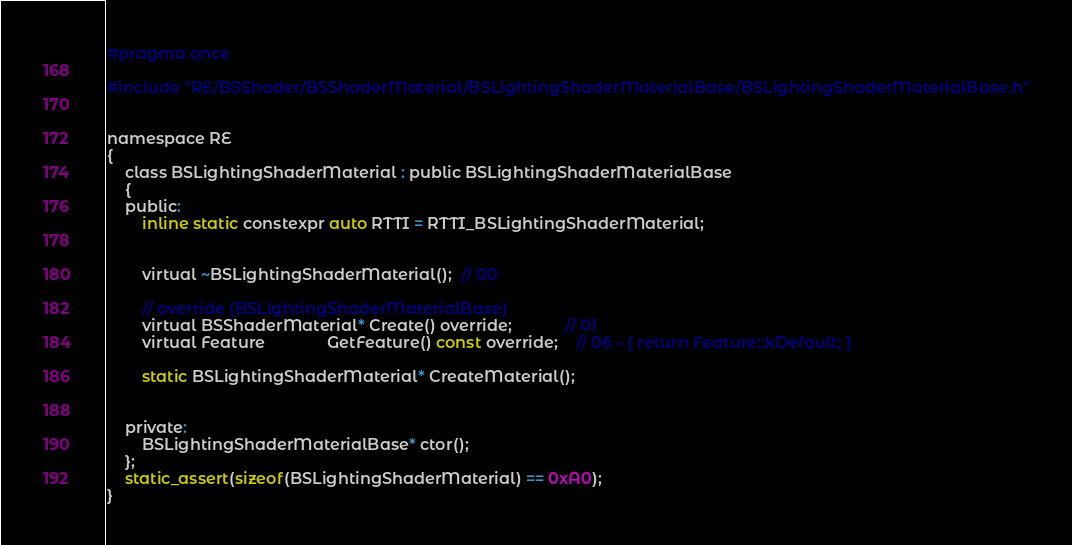<code> <loc_0><loc_0><loc_500><loc_500><_C_>#pragma once

#include "RE/BSShader/BSShaderMaterial/BSLightingShaderMaterialBase/BSLightingShaderMaterialBase.h"


namespace RE
{
	class BSLightingShaderMaterial : public BSLightingShaderMaterialBase
	{
	public:
		inline static constexpr auto RTTI = RTTI_BSLightingShaderMaterial;


		virtual ~BSLightingShaderMaterial();  // 00

		// override (BSLightingShaderMaterialBase)
		virtual BSShaderMaterial* Create() override;			// 01
		virtual Feature			  GetFeature() const override;	// 06 - { return Feature::kDefault; }

		static BSLightingShaderMaterial* CreateMaterial();


	private:
		BSLightingShaderMaterialBase* ctor();
	};
	static_assert(sizeof(BSLightingShaderMaterial) == 0xA0);
}
</code> 